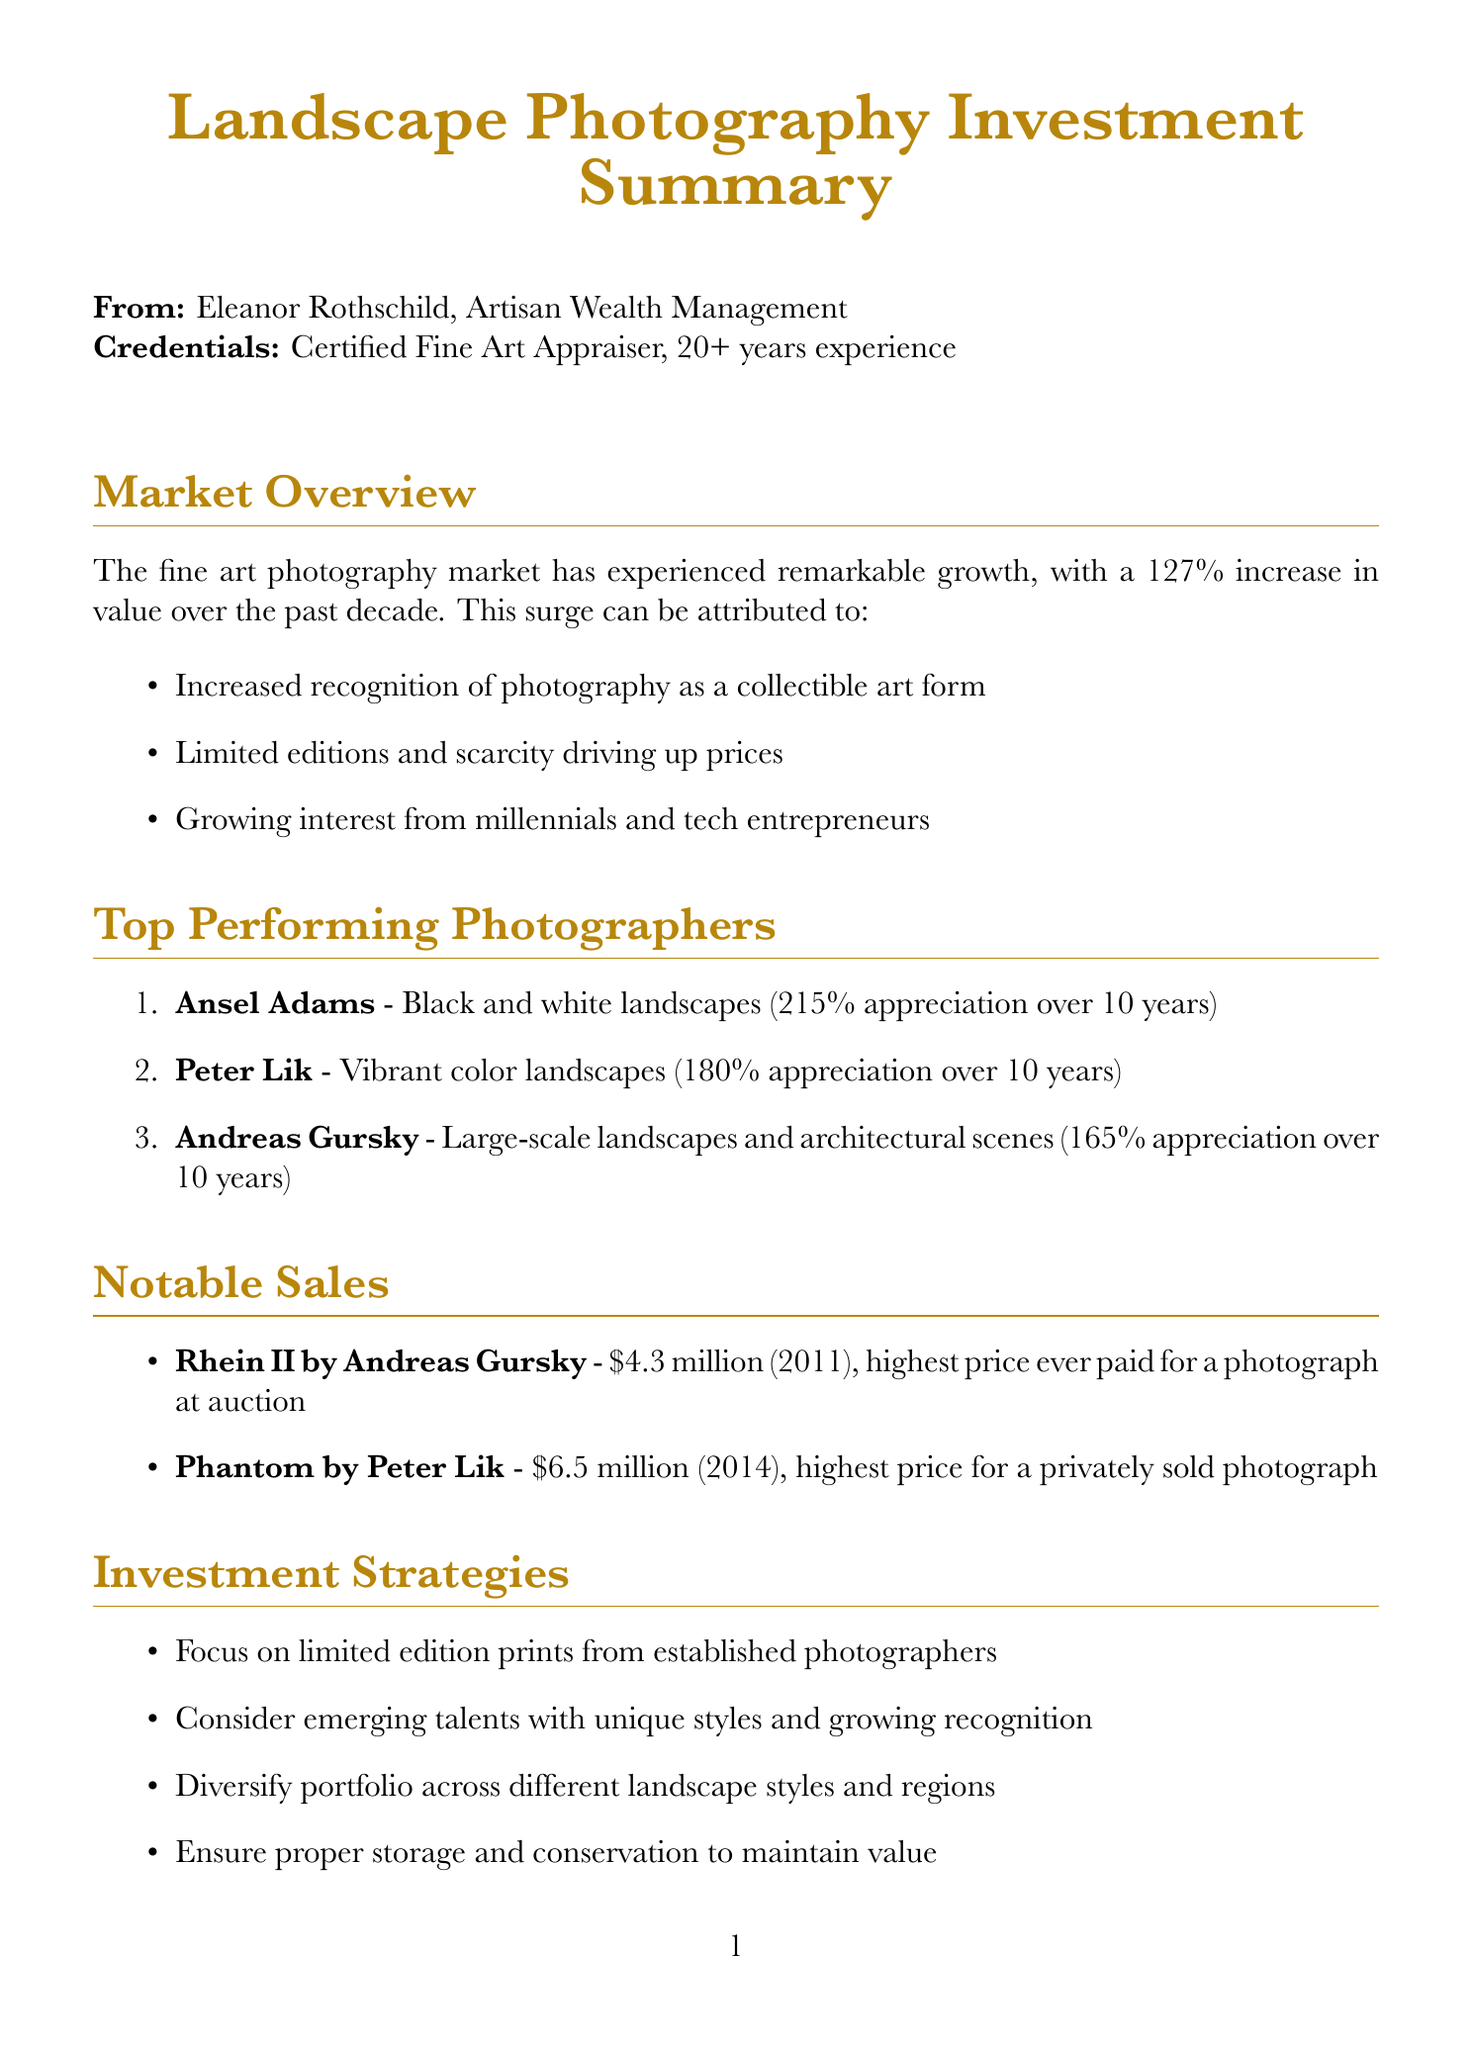What is the name of the fine art advisor? The document states that the fine art advisor is Eleanor Rothschild.
Answer: Eleanor Rothschild What is the decade growth percentage of the fine art photography market? The document mentions a 127% increase in value over the past decade.
Answer: 127% Which photographer has an average appreciation of 215%? The document lists Ansel Adams with an average appreciation of 215% over 10 years.
Answer: Ansel Adams What is the highest sale price for a photograph at auction? According to the document, the highest sale price is $4.3 million for Rhein II by Andreas Gursky.
Answer: $4.3 million What is the expected annual appreciation over the next 5 years? The document forecasts an 8-12% annual appreciation over the next 5 years.
Answer: 8-12% Which gallery is recommended for blue-chip contemporary photographers? The document recommends Gagosian Gallery for blue-chip contemporary photographers.
Answer: Gagosian Gallery What tax applies to sales of artwork held for more than one year? The document states that long-term capital gains tax applies to such sales.
Answer: Long-term capital gains tax What is a suggested strategy for maintaining the value of artwork? The document suggests ensuring proper storage and conservation to maintain value.
Answer: Proper storage and conservation 